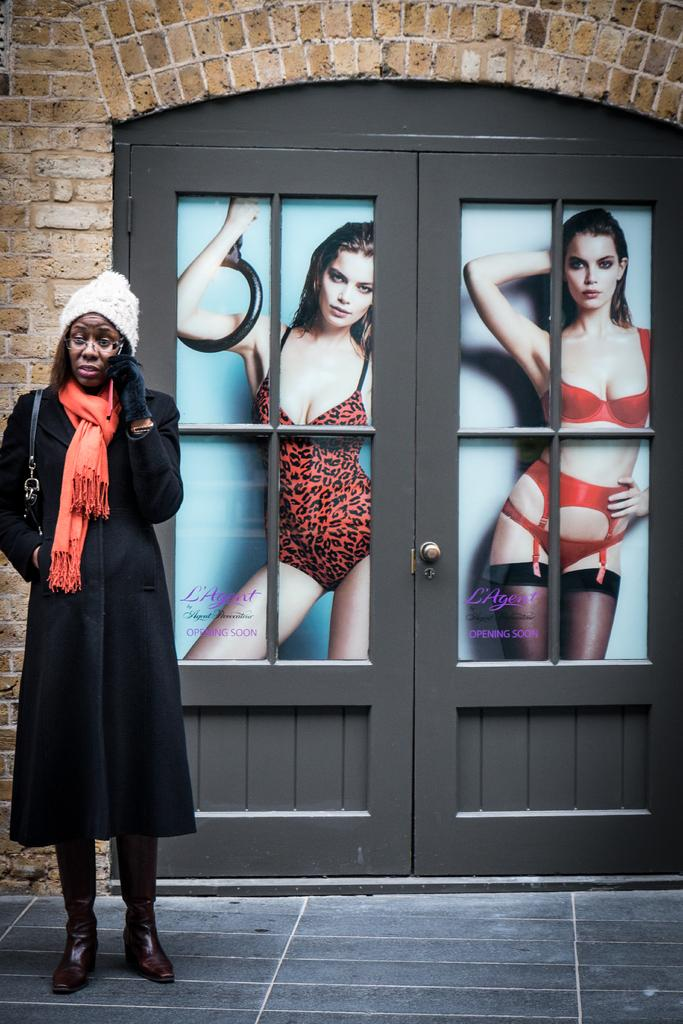Who is the main subject in the image? There is a woman in the image. What is the woman doing in the image? The woman is standing on the floor. Can you describe the woman's appearance? The woman is wearing spectacles. What can be seen in the background of the image? There is a wall, a door, and posters in the background of the image. What type of lumber is the woman using to build a table in the image? There is no lumber or table-building activity present in the image. How many sisters does the woman have in the image? There is no information about the woman's sisters in the image. 